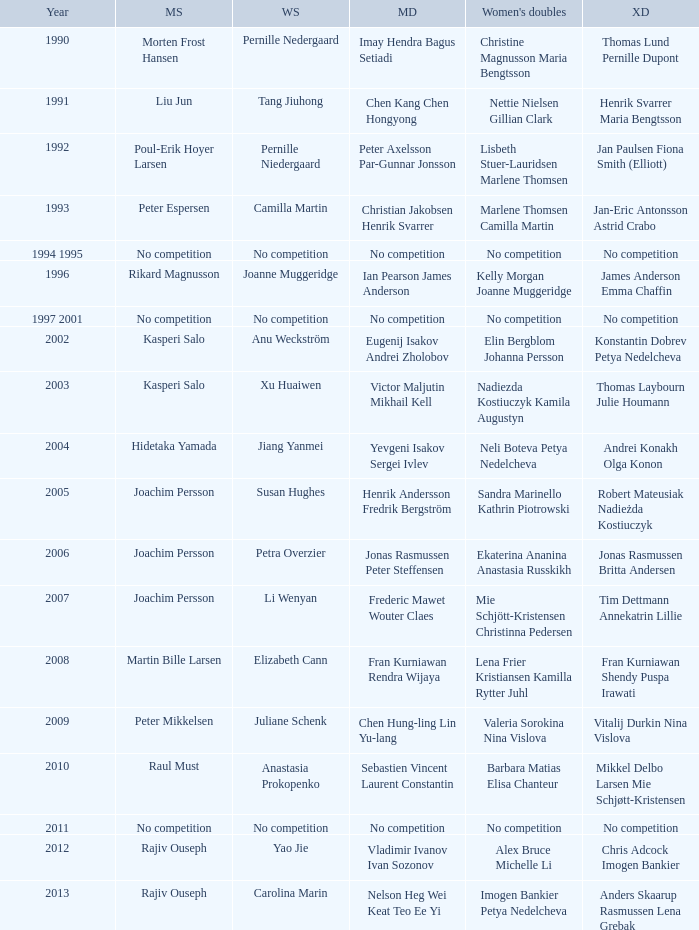Who won the Mixed Doubles in 2007? Tim Dettmann Annekatrin Lillie. 